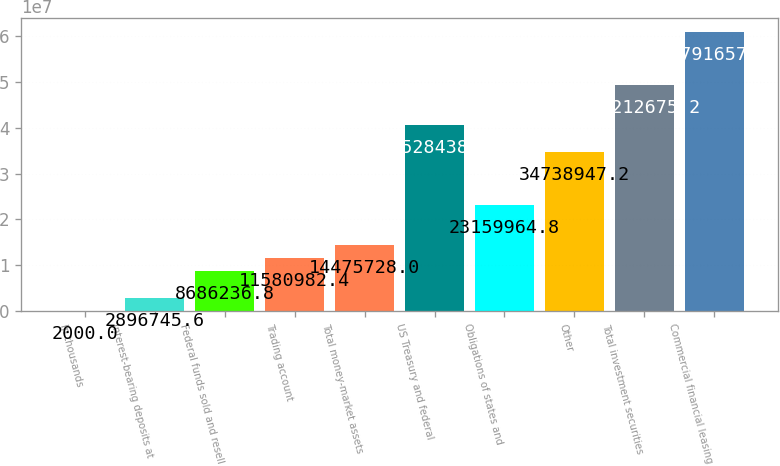Convert chart to OTSL. <chart><loc_0><loc_0><loc_500><loc_500><bar_chart><fcel>In thousands<fcel>Interest-bearing deposits at<fcel>Federal funds sold and resell<fcel>Trading account<fcel>Total money-market assets<fcel>US Treasury and federal<fcel>Obligations of states and<fcel>Other<fcel>Total investment securities<fcel>Commercial financial leasing<nl><fcel>2000<fcel>2.89675e+06<fcel>8.68624e+06<fcel>1.1581e+07<fcel>1.44757e+07<fcel>4.05284e+07<fcel>2.316e+07<fcel>3.47389e+07<fcel>4.92127e+07<fcel>6.07917e+07<nl></chart> 